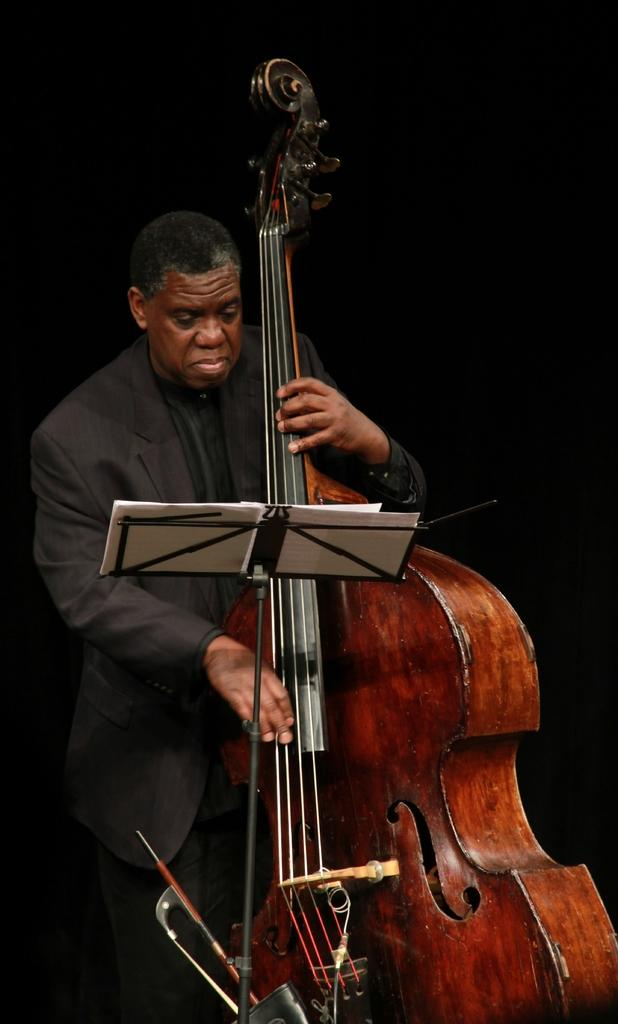Who is the person in the image? There is a man in the image. What is the man holding in the image? The man is holding a violin. What is the man standing in front of in the image? The man is standing in front of a table. What is on the table in the image? There is a book on the table. What type of leaf can be seen falling from the sky in the image? There is no leaf falling from the sky in the image. 